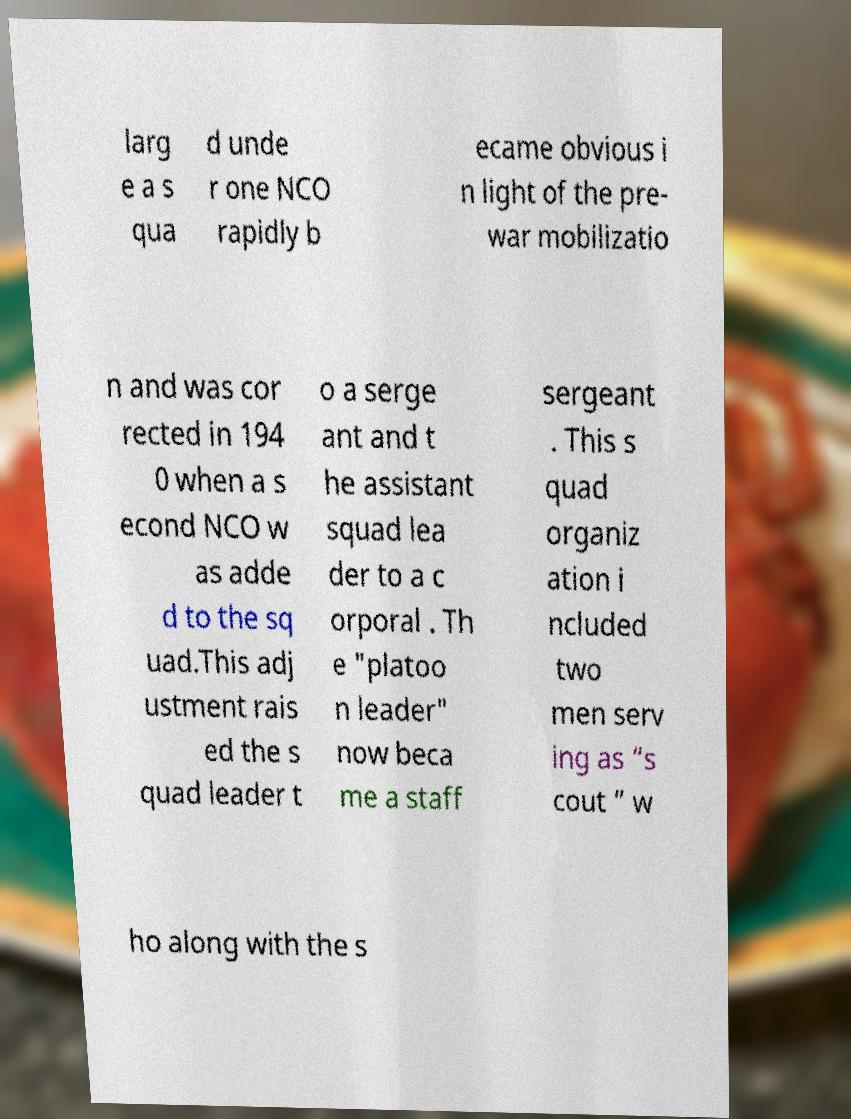Could you assist in decoding the text presented in this image and type it out clearly? larg e a s qua d unde r one NCO rapidly b ecame obvious i n light of the pre- war mobilizatio n and was cor rected in 194 0 when a s econd NCO w as adde d to the sq uad.This adj ustment rais ed the s quad leader t o a serge ant and t he assistant squad lea der to a c orporal . Th e "platoo n leader" now beca me a staff sergeant . This s quad organiz ation i ncluded two men serv ing as “s cout ” w ho along with the s 